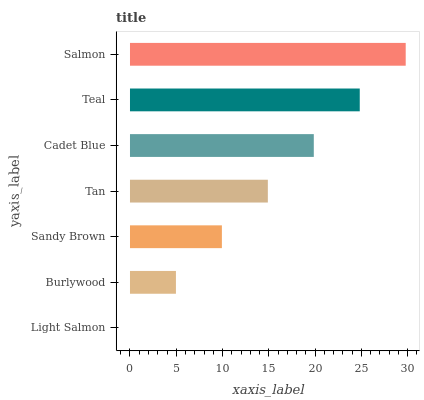Is Light Salmon the minimum?
Answer yes or no. Yes. Is Salmon the maximum?
Answer yes or no. Yes. Is Burlywood the minimum?
Answer yes or no. No. Is Burlywood the maximum?
Answer yes or no. No. Is Burlywood greater than Light Salmon?
Answer yes or no. Yes. Is Light Salmon less than Burlywood?
Answer yes or no. Yes. Is Light Salmon greater than Burlywood?
Answer yes or no. No. Is Burlywood less than Light Salmon?
Answer yes or no. No. Is Tan the high median?
Answer yes or no. Yes. Is Tan the low median?
Answer yes or no. Yes. Is Sandy Brown the high median?
Answer yes or no. No. Is Cadet Blue the low median?
Answer yes or no. No. 